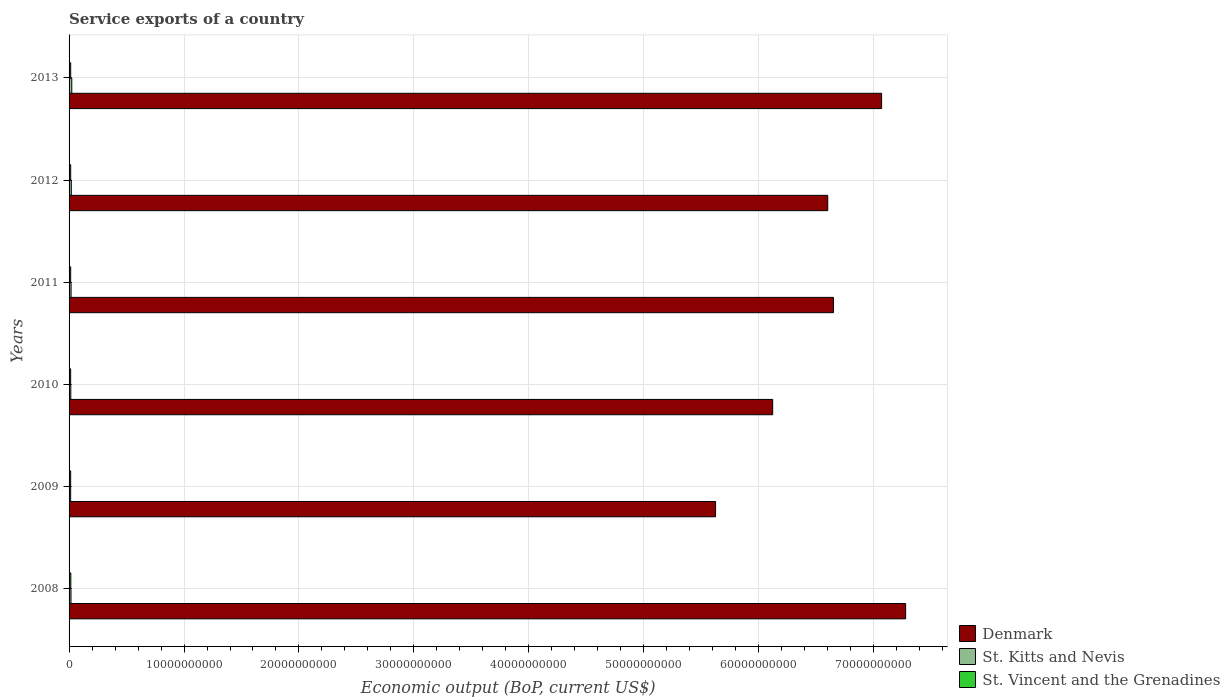Are the number of bars per tick equal to the number of legend labels?
Give a very brief answer. Yes. Are the number of bars on each tick of the Y-axis equal?
Provide a succinct answer. Yes. How many bars are there on the 3rd tick from the top?
Your answer should be very brief. 3. How many bars are there on the 1st tick from the bottom?
Offer a terse response. 3. What is the label of the 1st group of bars from the top?
Offer a terse response. 2013. What is the service exports in St. Kitts and Nevis in 2008?
Make the answer very short. 1.66e+08. Across all years, what is the maximum service exports in St. Vincent and the Grenadines?
Your answer should be very brief. 1.53e+08. Across all years, what is the minimum service exports in St. Kitts and Nevis?
Provide a succinct answer. 1.37e+08. In which year was the service exports in St. Kitts and Nevis maximum?
Offer a very short reply. 2013. In which year was the service exports in St. Kitts and Nevis minimum?
Make the answer very short. 2009. What is the total service exports in St. Kitts and Nevis in the graph?
Ensure brevity in your answer.  1.06e+09. What is the difference between the service exports in Denmark in 2010 and that in 2012?
Your answer should be compact. -4.79e+09. What is the difference between the service exports in Denmark in 2011 and the service exports in St. Kitts and Nevis in 2008?
Make the answer very short. 6.63e+1. What is the average service exports in St. Kitts and Nevis per year?
Give a very brief answer. 1.76e+08. In the year 2008, what is the difference between the service exports in St. Kitts and Nevis and service exports in St. Vincent and the Grenadines?
Offer a terse response. 1.28e+07. What is the ratio of the service exports in St. Kitts and Nevis in 2008 to that in 2013?
Keep it short and to the point. 0.7. Is the service exports in St. Kitts and Nevis in 2008 less than that in 2011?
Offer a terse response. Yes. What is the difference between the highest and the second highest service exports in St. Kitts and Nevis?
Provide a short and direct response. 4.17e+07. What is the difference between the highest and the lowest service exports in St. Vincent and the Grenadines?
Offer a terse response. 1.48e+07. What does the 1st bar from the top in 2013 represents?
Your answer should be compact. St. Vincent and the Grenadines. What does the 2nd bar from the bottom in 2008 represents?
Your answer should be very brief. St. Kitts and Nevis. Is it the case that in every year, the sum of the service exports in St. Vincent and the Grenadines and service exports in Denmark is greater than the service exports in St. Kitts and Nevis?
Ensure brevity in your answer.  Yes. How many bars are there?
Make the answer very short. 18. How many years are there in the graph?
Your answer should be compact. 6. What is the difference between two consecutive major ticks on the X-axis?
Give a very brief answer. 1.00e+1. Does the graph contain grids?
Keep it short and to the point. Yes. Where does the legend appear in the graph?
Ensure brevity in your answer.  Bottom right. How are the legend labels stacked?
Give a very brief answer. Vertical. What is the title of the graph?
Offer a very short reply. Service exports of a country. Does "Aruba" appear as one of the legend labels in the graph?
Provide a succinct answer. No. What is the label or title of the X-axis?
Your answer should be compact. Economic output (BoP, current US$). What is the label or title of the Y-axis?
Provide a short and direct response. Years. What is the Economic output (BoP, current US$) in Denmark in 2008?
Offer a very short reply. 7.28e+1. What is the Economic output (BoP, current US$) of St. Kitts and Nevis in 2008?
Your response must be concise. 1.66e+08. What is the Economic output (BoP, current US$) in St. Vincent and the Grenadines in 2008?
Make the answer very short. 1.53e+08. What is the Economic output (BoP, current US$) of Denmark in 2009?
Offer a very short reply. 5.62e+1. What is the Economic output (BoP, current US$) of St. Kitts and Nevis in 2009?
Offer a terse response. 1.37e+08. What is the Economic output (BoP, current US$) in St. Vincent and the Grenadines in 2009?
Offer a terse response. 1.39e+08. What is the Economic output (BoP, current US$) of Denmark in 2010?
Your answer should be compact. 6.12e+1. What is the Economic output (BoP, current US$) in St. Kitts and Nevis in 2010?
Your response must be concise. 1.50e+08. What is the Economic output (BoP, current US$) of St. Vincent and the Grenadines in 2010?
Make the answer very short. 1.38e+08. What is the Economic output (BoP, current US$) in Denmark in 2011?
Make the answer very short. 6.65e+1. What is the Economic output (BoP, current US$) of St. Kitts and Nevis in 2011?
Your answer should be compact. 1.75e+08. What is the Economic output (BoP, current US$) in St. Vincent and the Grenadines in 2011?
Offer a terse response. 1.39e+08. What is the Economic output (BoP, current US$) in Denmark in 2012?
Your answer should be very brief. 6.60e+1. What is the Economic output (BoP, current US$) in St. Kitts and Nevis in 2012?
Ensure brevity in your answer.  1.94e+08. What is the Economic output (BoP, current US$) in St. Vincent and the Grenadines in 2012?
Provide a short and direct response. 1.40e+08. What is the Economic output (BoP, current US$) in Denmark in 2013?
Make the answer very short. 7.07e+1. What is the Economic output (BoP, current US$) in St. Kitts and Nevis in 2013?
Your answer should be compact. 2.36e+08. What is the Economic output (BoP, current US$) in St. Vincent and the Grenadines in 2013?
Ensure brevity in your answer.  1.41e+08. Across all years, what is the maximum Economic output (BoP, current US$) in Denmark?
Make the answer very short. 7.28e+1. Across all years, what is the maximum Economic output (BoP, current US$) in St. Kitts and Nevis?
Give a very brief answer. 2.36e+08. Across all years, what is the maximum Economic output (BoP, current US$) in St. Vincent and the Grenadines?
Provide a short and direct response. 1.53e+08. Across all years, what is the minimum Economic output (BoP, current US$) in Denmark?
Give a very brief answer. 5.62e+1. Across all years, what is the minimum Economic output (BoP, current US$) of St. Kitts and Nevis?
Make the answer very short. 1.37e+08. Across all years, what is the minimum Economic output (BoP, current US$) of St. Vincent and the Grenadines?
Your response must be concise. 1.38e+08. What is the total Economic output (BoP, current US$) in Denmark in the graph?
Provide a short and direct response. 3.93e+11. What is the total Economic output (BoP, current US$) in St. Kitts and Nevis in the graph?
Provide a short and direct response. 1.06e+09. What is the total Economic output (BoP, current US$) in St. Vincent and the Grenadines in the graph?
Ensure brevity in your answer.  8.51e+08. What is the difference between the Economic output (BoP, current US$) in Denmark in 2008 and that in 2009?
Provide a short and direct response. 1.65e+1. What is the difference between the Economic output (BoP, current US$) of St. Kitts and Nevis in 2008 and that in 2009?
Provide a succinct answer. 2.85e+07. What is the difference between the Economic output (BoP, current US$) of St. Vincent and the Grenadines in 2008 and that in 2009?
Provide a short and direct response. 1.40e+07. What is the difference between the Economic output (BoP, current US$) in Denmark in 2008 and that in 2010?
Ensure brevity in your answer.  1.16e+1. What is the difference between the Economic output (BoP, current US$) of St. Kitts and Nevis in 2008 and that in 2010?
Keep it short and to the point. 1.56e+07. What is the difference between the Economic output (BoP, current US$) in St. Vincent and the Grenadines in 2008 and that in 2010?
Ensure brevity in your answer.  1.48e+07. What is the difference between the Economic output (BoP, current US$) of Denmark in 2008 and that in 2011?
Make the answer very short. 6.28e+09. What is the difference between the Economic output (BoP, current US$) of St. Kitts and Nevis in 2008 and that in 2011?
Your answer should be very brief. -9.02e+06. What is the difference between the Economic output (BoP, current US$) of St. Vincent and the Grenadines in 2008 and that in 2011?
Your response must be concise. 1.36e+07. What is the difference between the Economic output (BoP, current US$) of Denmark in 2008 and that in 2012?
Provide a succinct answer. 6.78e+09. What is the difference between the Economic output (BoP, current US$) of St. Kitts and Nevis in 2008 and that in 2012?
Offer a terse response. -2.86e+07. What is the difference between the Economic output (BoP, current US$) of St. Vincent and the Grenadines in 2008 and that in 2012?
Your answer should be very brief. 1.25e+07. What is the difference between the Economic output (BoP, current US$) in Denmark in 2008 and that in 2013?
Provide a succinct answer. 2.09e+09. What is the difference between the Economic output (BoP, current US$) in St. Kitts and Nevis in 2008 and that in 2013?
Provide a succinct answer. -7.04e+07. What is the difference between the Economic output (BoP, current US$) of St. Vincent and the Grenadines in 2008 and that in 2013?
Your response must be concise. 1.23e+07. What is the difference between the Economic output (BoP, current US$) in Denmark in 2009 and that in 2010?
Make the answer very short. -4.97e+09. What is the difference between the Economic output (BoP, current US$) in St. Kitts and Nevis in 2009 and that in 2010?
Offer a terse response. -1.29e+07. What is the difference between the Economic output (BoP, current US$) of St. Vincent and the Grenadines in 2009 and that in 2010?
Your answer should be very brief. 7.68e+05. What is the difference between the Economic output (BoP, current US$) of Denmark in 2009 and that in 2011?
Ensure brevity in your answer.  -1.03e+1. What is the difference between the Economic output (BoP, current US$) in St. Kitts and Nevis in 2009 and that in 2011?
Your answer should be very brief. -3.75e+07. What is the difference between the Economic output (BoP, current US$) in St. Vincent and the Grenadines in 2009 and that in 2011?
Provide a short and direct response. -4.17e+05. What is the difference between the Economic output (BoP, current US$) of Denmark in 2009 and that in 2012?
Offer a terse response. -9.76e+09. What is the difference between the Economic output (BoP, current US$) of St. Kitts and Nevis in 2009 and that in 2012?
Keep it short and to the point. -5.71e+07. What is the difference between the Economic output (BoP, current US$) in St. Vincent and the Grenadines in 2009 and that in 2012?
Your response must be concise. -1.53e+06. What is the difference between the Economic output (BoP, current US$) of Denmark in 2009 and that in 2013?
Provide a short and direct response. -1.44e+1. What is the difference between the Economic output (BoP, current US$) of St. Kitts and Nevis in 2009 and that in 2013?
Your response must be concise. -9.88e+07. What is the difference between the Economic output (BoP, current US$) of St. Vincent and the Grenadines in 2009 and that in 2013?
Ensure brevity in your answer.  -1.71e+06. What is the difference between the Economic output (BoP, current US$) of Denmark in 2010 and that in 2011?
Offer a very short reply. -5.28e+09. What is the difference between the Economic output (BoP, current US$) in St. Kitts and Nevis in 2010 and that in 2011?
Provide a succinct answer. -2.46e+07. What is the difference between the Economic output (BoP, current US$) of St. Vincent and the Grenadines in 2010 and that in 2011?
Your answer should be compact. -1.19e+06. What is the difference between the Economic output (BoP, current US$) of Denmark in 2010 and that in 2012?
Offer a terse response. -4.79e+09. What is the difference between the Economic output (BoP, current US$) in St. Kitts and Nevis in 2010 and that in 2012?
Your answer should be compact. -4.42e+07. What is the difference between the Economic output (BoP, current US$) in St. Vincent and the Grenadines in 2010 and that in 2012?
Give a very brief answer. -2.30e+06. What is the difference between the Economic output (BoP, current US$) of Denmark in 2010 and that in 2013?
Ensure brevity in your answer.  -9.47e+09. What is the difference between the Economic output (BoP, current US$) in St. Kitts and Nevis in 2010 and that in 2013?
Provide a short and direct response. -8.59e+07. What is the difference between the Economic output (BoP, current US$) of St. Vincent and the Grenadines in 2010 and that in 2013?
Your response must be concise. -2.48e+06. What is the difference between the Economic output (BoP, current US$) in Denmark in 2011 and that in 2012?
Your answer should be compact. 4.95e+08. What is the difference between the Economic output (BoP, current US$) of St. Kitts and Nevis in 2011 and that in 2012?
Your answer should be very brief. -1.96e+07. What is the difference between the Economic output (BoP, current US$) of St. Vincent and the Grenadines in 2011 and that in 2012?
Your answer should be very brief. -1.12e+06. What is the difference between the Economic output (BoP, current US$) in Denmark in 2011 and that in 2013?
Your answer should be compact. -4.19e+09. What is the difference between the Economic output (BoP, current US$) of St. Kitts and Nevis in 2011 and that in 2013?
Provide a succinct answer. -6.13e+07. What is the difference between the Economic output (BoP, current US$) of St. Vincent and the Grenadines in 2011 and that in 2013?
Your answer should be compact. -1.30e+06. What is the difference between the Economic output (BoP, current US$) of Denmark in 2012 and that in 2013?
Give a very brief answer. -4.69e+09. What is the difference between the Economic output (BoP, current US$) in St. Kitts and Nevis in 2012 and that in 2013?
Your answer should be compact. -4.17e+07. What is the difference between the Economic output (BoP, current US$) of St. Vincent and the Grenadines in 2012 and that in 2013?
Give a very brief answer. -1.79e+05. What is the difference between the Economic output (BoP, current US$) of Denmark in 2008 and the Economic output (BoP, current US$) of St. Kitts and Nevis in 2009?
Offer a very short reply. 7.26e+1. What is the difference between the Economic output (BoP, current US$) in Denmark in 2008 and the Economic output (BoP, current US$) in St. Vincent and the Grenadines in 2009?
Offer a very short reply. 7.26e+1. What is the difference between the Economic output (BoP, current US$) in St. Kitts and Nevis in 2008 and the Economic output (BoP, current US$) in St. Vincent and the Grenadines in 2009?
Your response must be concise. 2.69e+07. What is the difference between the Economic output (BoP, current US$) of Denmark in 2008 and the Economic output (BoP, current US$) of St. Kitts and Nevis in 2010?
Your answer should be very brief. 7.26e+1. What is the difference between the Economic output (BoP, current US$) in Denmark in 2008 and the Economic output (BoP, current US$) in St. Vincent and the Grenadines in 2010?
Your answer should be compact. 7.26e+1. What is the difference between the Economic output (BoP, current US$) of St. Kitts and Nevis in 2008 and the Economic output (BoP, current US$) of St. Vincent and the Grenadines in 2010?
Keep it short and to the point. 2.76e+07. What is the difference between the Economic output (BoP, current US$) of Denmark in 2008 and the Economic output (BoP, current US$) of St. Kitts and Nevis in 2011?
Provide a succinct answer. 7.26e+1. What is the difference between the Economic output (BoP, current US$) of Denmark in 2008 and the Economic output (BoP, current US$) of St. Vincent and the Grenadines in 2011?
Your answer should be compact. 7.26e+1. What is the difference between the Economic output (BoP, current US$) in St. Kitts and Nevis in 2008 and the Economic output (BoP, current US$) in St. Vincent and the Grenadines in 2011?
Keep it short and to the point. 2.64e+07. What is the difference between the Economic output (BoP, current US$) of Denmark in 2008 and the Economic output (BoP, current US$) of St. Kitts and Nevis in 2012?
Provide a short and direct response. 7.26e+1. What is the difference between the Economic output (BoP, current US$) of Denmark in 2008 and the Economic output (BoP, current US$) of St. Vincent and the Grenadines in 2012?
Your answer should be very brief. 7.26e+1. What is the difference between the Economic output (BoP, current US$) in St. Kitts and Nevis in 2008 and the Economic output (BoP, current US$) in St. Vincent and the Grenadines in 2012?
Your answer should be very brief. 2.53e+07. What is the difference between the Economic output (BoP, current US$) of Denmark in 2008 and the Economic output (BoP, current US$) of St. Kitts and Nevis in 2013?
Keep it short and to the point. 7.25e+1. What is the difference between the Economic output (BoP, current US$) in Denmark in 2008 and the Economic output (BoP, current US$) in St. Vincent and the Grenadines in 2013?
Ensure brevity in your answer.  7.26e+1. What is the difference between the Economic output (BoP, current US$) of St. Kitts and Nevis in 2008 and the Economic output (BoP, current US$) of St. Vincent and the Grenadines in 2013?
Your answer should be compact. 2.52e+07. What is the difference between the Economic output (BoP, current US$) of Denmark in 2009 and the Economic output (BoP, current US$) of St. Kitts and Nevis in 2010?
Your answer should be compact. 5.61e+1. What is the difference between the Economic output (BoP, current US$) of Denmark in 2009 and the Economic output (BoP, current US$) of St. Vincent and the Grenadines in 2010?
Provide a succinct answer. 5.61e+1. What is the difference between the Economic output (BoP, current US$) of St. Kitts and Nevis in 2009 and the Economic output (BoP, current US$) of St. Vincent and the Grenadines in 2010?
Your response must be concise. -8.49e+05. What is the difference between the Economic output (BoP, current US$) in Denmark in 2009 and the Economic output (BoP, current US$) in St. Kitts and Nevis in 2011?
Keep it short and to the point. 5.61e+1. What is the difference between the Economic output (BoP, current US$) of Denmark in 2009 and the Economic output (BoP, current US$) of St. Vincent and the Grenadines in 2011?
Your answer should be very brief. 5.61e+1. What is the difference between the Economic output (BoP, current US$) in St. Kitts and Nevis in 2009 and the Economic output (BoP, current US$) in St. Vincent and the Grenadines in 2011?
Your answer should be very brief. -2.03e+06. What is the difference between the Economic output (BoP, current US$) of Denmark in 2009 and the Economic output (BoP, current US$) of St. Kitts and Nevis in 2012?
Provide a succinct answer. 5.60e+1. What is the difference between the Economic output (BoP, current US$) of Denmark in 2009 and the Economic output (BoP, current US$) of St. Vincent and the Grenadines in 2012?
Give a very brief answer. 5.61e+1. What is the difference between the Economic output (BoP, current US$) of St. Kitts and Nevis in 2009 and the Economic output (BoP, current US$) of St. Vincent and the Grenadines in 2012?
Offer a very short reply. -3.15e+06. What is the difference between the Economic output (BoP, current US$) of Denmark in 2009 and the Economic output (BoP, current US$) of St. Kitts and Nevis in 2013?
Your answer should be compact. 5.60e+1. What is the difference between the Economic output (BoP, current US$) in Denmark in 2009 and the Economic output (BoP, current US$) in St. Vincent and the Grenadines in 2013?
Your response must be concise. 5.61e+1. What is the difference between the Economic output (BoP, current US$) of St. Kitts and Nevis in 2009 and the Economic output (BoP, current US$) of St. Vincent and the Grenadines in 2013?
Your answer should be compact. -3.33e+06. What is the difference between the Economic output (BoP, current US$) of Denmark in 2010 and the Economic output (BoP, current US$) of St. Kitts and Nevis in 2011?
Your answer should be very brief. 6.10e+1. What is the difference between the Economic output (BoP, current US$) of Denmark in 2010 and the Economic output (BoP, current US$) of St. Vincent and the Grenadines in 2011?
Your answer should be compact. 6.11e+1. What is the difference between the Economic output (BoP, current US$) of St. Kitts and Nevis in 2010 and the Economic output (BoP, current US$) of St. Vincent and the Grenadines in 2011?
Keep it short and to the point. 1.09e+07. What is the difference between the Economic output (BoP, current US$) of Denmark in 2010 and the Economic output (BoP, current US$) of St. Kitts and Nevis in 2012?
Your response must be concise. 6.10e+1. What is the difference between the Economic output (BoP, current US$) of Denmark in 2010 and the Economic output (BoP, current US$) of St. Vincent and the Grenadines in 2012?
Give a very brief answer. 6.11e+1. What is the difference between the Economic output (BoP, current US$) in St. Kitts and Nevis in 2010 and the Economic output (BoP, current US$) in St. Vincent and the Grenadines in 2012?
Offer a very short reply. 9.74e+06. What is the difference between the Economic output (BoP, current US$) in Denmark in 2010 and the Economic output (BoP, current US$) in St. Kitts and Nevis in 2013?
Ensure brevity in your answer.  6.10e+1. What is the difference between the Economic output (BoP, current US$) of Denmark in 2010 and the Economic output (BoP, current US$) of St. Vincent and the Grenadines in 2013?
Offer a terse response. 6.11e+1. What is the difference between the Economic output (BoP, current US$) of St. Kitts and Nevis in 2010 and the Economic output (BoP, current US$) of St. Vincent and the Grenadines in 2013?
Keep it short and to the point. 9.56e+06. What is the difference between the Economic output (BoP, current US$) of Denmark in 2011 and the Economic output (BoP, current US$) of St. Kitts and Nevis in 2012?
Offer a very short reply. 6.63e+1. What is the difference between the Economic output (BoP, current US$) of Denmark in 2011 and the Economic output (BoP, current US$) of St. Vincent and the Grenadines in 2012?
Make the answer very short. 6.64e+1. What is the difference between the Economic output (BoP, current US$) in St. Kitts and Nevis in 2011 and the Economic output (BoP, current US$) in St. Vincent and the Grenadines in 2012?
Offer a terse response. 3.43e+07. What is the difference between the Economic output (BoP, current US$) of Denmark in 2011 and the Economic output (BoP, current US$) of St. Kitts and Nevis in 2013?
Ensure brevity in your answer.  6.63e+1. What is the difference between the Economic output (BoP, current US$) of Denmark in 2011 and the Economic output (BoP, current US$) of St. Vincent and the Grenadines in 2013?
Offer a terse response. 6.64e+1. What is the difference between the Economic output (BoP, current US$) in St. Kitts and Nevis in 2011 and the Economic output (BoP, current US$) in St. Vincent and the Grenadines in 2013?
Your response must be concise. 3.42e+07. What is the difference between the Economic output (BoP, current US$) of Denmark in 2012 and the Economic output (BoP, current US$) of St. Kitts and Nevis in 2013?
Your answer should be compact. 6.58e+1. What is the difference between the Economic output (BoP, current US$) of Denmark in 2012 and the Economic output (BoP, current US$) of St. Vincent and the Grenadines in 2013?
Your answer should be compact. 6.59e+1. What is the difference between the Economic output (BoP, current US$) of St. Kitts and Nevis in 2012 and the Economic output (BoP, current US$) of St. Vincent and the Grenadines in 2013?
Offer a very short reply. 5.38e+07. What is the average Economic output (BoP, current US$) in Denmark per year?
Ensure brevity in your answer.  6.56e+1. What is the average Economic output (BoP, current US$) in St. Kitts and Nevis per year?
Ensure brevity in your answer.  1.76e+08. What is the average Economic output (BoP, current US$) of St. Vincent and the Grenadines per year?
Your answer should be very brief. 1.42e+08. In the year 2008, what is the difference between the Economic output (BoP, current US$) of Denmark and Economic output (BoP, current US$) of St. Kitts and Nevis?
Make the answer very short. 7.26e+1. In the year 2008, what is the difference between the Economic output (BoP, current US$) of Denmark and Economic output (BoP, current US$) of St. Vincent and the Grenadines?
Ensure brevity in your answer.  7.26e+1. In the year 2008, what is the difference between the Economic output (BoP, current US$) of St. Kitts and Nevis and Economic output (BoP, current US$) of St. Vincent and the Grenadines?
Your answer should be compact. 1.28e+07. In the year 2009, what is the difference between the Economic output (BoP, current US$) of Denmark and Economic output (BoP, current US$) of St. Kitts and Nevis?
Your answer should be compact. 5.61e+1. In the year 2009, what is the difference between the Economic output (BoP, current US$) in Denmark and Economic output (BoP, current US$) in St. Vincent and the Grenadines?
Offer a very short reply. 5.61e+1. In the year 2009, what is the difference between the Economic output (BoP, current US$) of St. Kitts and Nevis and Economic output (BoP, current US$) of St. Vincent and the Grenadines?
Offer a terse response. -1.62e+06. In the year 2010, what is the difference between the Economic output (BoP, current US$) of Denmark and Economic output (BoP, current US$) of St. Kitts and Nevis?
Provide a succinct answer. 6.11e+1. In the year 2010, what is the difference between the Economic output (BoP, current US$) in Denmark and Economic output (BoP, current US$) in St. Vincent and the Grenadines?
Offer a very short reply. 6.11e+1. In the year 2010, what is the difference between the Economic output (BoP, current US$) of St. Kitts and Nevis and Economic output (BoP, current US$) of St. Vincent and the Grenadines?
Your answer should be compact. 1.20e+07. In the year 2011, what is the difference between the Economic output (BoP, current US$) of Denmark and Economic output (BoP, current US$) of St. Kitts and Nevis?
Your response must be concise. 6.63e+1. In the year 2011, what is the difference between the Economic output (BoP, current US$) of Denmark and Economic output (BoP, current US$) of St. Vincent and the Grenadines?
Offer a terse response. 6.64e+1. In the year 2011, what is the difference between the Economic output (BoP, current US$) in St. Kitts and Nevis and Economic output (BoP, current US$) in St. Vincent and the Grenadines?
Your answer should be compact. 3.55e+07. In the year 2012, what is the difference between the Economic output (BoP, current US$) of Denmark and Economic output (BoP, current US$) of St. Kitts and Nevis?
Keep it short and to the point. 6.58e+1. In the year 2012, what is the difference between the Economic output (BoP, current US$) of Denmark and Economic output (BoP, current US$) of St. Vincent and the Grenadines?
Offer a very short reply. 6.59e+1. In the year 2012, what is the difference between the Economic output (BoP, current US$) in St. Kitts and Nevis and Economic output (BoP, current US$) in St. Vincent and the Grenadines?
Make the answer very short. 5.39e+07. In the year 2013, what is the difference between the Economic output (BoP, current US$) of Denmark and Economic output (BoP, current US$) of St. Kitts and Nevis?
Offer a very short reply. 7.04e+1. In the year 2013, what is the difference between the Economic output (BoP, current US$) of Denmark and Economic output (BoP, current US$) of St. Vincent and the Grenadines?
Make the answer very short. 7.05e+1. In the year 2013, what is the difference between the Economic output (BoP, current US$) of St. Kitts and Nevis and Economic output (BoP, current US$) of St. Vincent and the Grenadines?
Your answer should be compact. 9.55e+07. What is the ratio of the Economic output (BoP, current US$) of Denmark in 2008 to that in 2009?
Give a very brief answer. 1.29. What is the ratio of the Economic output (BoP, current US$) of St. Kitts and Nevis in 2008 to that in 2009?
Your response must be concise. 1.21. What is the ratio of the Economic output (BoP, current US$) in St. Vincent and the Grenadines in 2008 to that in 2009?
Offer a terse response. 1.1. What is the ratio of the Economic output (BoP, current US$) of Denmark in 2008 to that in 2010?
Your answer should be very brief. 1.19. What is the ratio of the Economic output (BoP, current US$) in St. Kitts and Nevis in 2008 to that in 2010?
Ensure brevity in your answer.  1.1. What is the ratio of the Economic output (BoP, current US$) in St. Vincent and the Grenadines in 2008 to that in 2010?
Offer a terse response. 1.11. What is the ratio of the Economic output (BoP, current US$) in Denmark in 2008 to that in 2011?
Your response must be concise. 1.09. What is the ratio of the Economic output (BoP, current US$) in St. Kitts and Nevis in 2008 to that in 2011?
Keep it short and to the point. 0.95. What is the ratio of the Economic output (BoP, current US$) of St. Vincent and the Grenadines in 2008 to that in 2011?
Your answer should be compact. 1.1. What is the ratio of the Economic output (BoP, current US$) in Denmark in 2008 to that in 2012?
Your answer should be very brief. 1.1. What is the ratio of the Economic output (BoP, current US$) of St. Kitts and Nevis in 2008 to that in 2012?
Ensure brevity in your answer.  0.85. What is the ratio of the Economic output (BoP, current US$) in St. Vincent and the Grenadines in 2008 to that in 2012?
Your response must be concise. 1.09. What is the ratio of the Economic output (BoP, current US$) in Denmark in 2008 to that in 2013?
Offer a very short reply. 1.03. What is the ratio of the Economic output (BoP, current US$) in St. Kitts and Nevis in 2008 to that in 2013?
Ensure brevity in your answer.  0.7. What is the ratio of the Economic output (BoP, current US$) in St. Vincent and the Grenadines in 2008 to that in 2013?
Keep it short and to the point. 1.09. What is the ratio of the Economic output (BoP, current US$) of Denmark in 2009 to that in 2010?
Keep it short and to the point. 0.92. What is the ratio of the Economic output (BoP, current US$) in St. Kitts and Nevis in 2009 to that in 2010?
Ensure brevity in your answer.  0.91. What is the ratio of the Economic output (BoP, current US$) of St. Vincent and the Grenadines in 2009 to that in 2010?
Your answer should be compact. 1.01. What is the ratio of the Economic output (BoP, current US$) in Denmark in 2009 to that in 2011?
Your answer should be compact. 0.85. What is the ratio of the Economic output (BoP, current US$) of St. Kitts and Nevis in 2009 to that in 2011?
Your answer should be compact. 0.79. What is the ratio of the Economic output (BoP, current US$) of St. Vincent and the Grenadines in 2009 to that in 2011?
Your answer should be very brief. 1. What is the ratio of the Economic output (BoP, current US$) in Denmark in 2009 to that in 2012?
Give a very brief answer. 0.85. What is the ratio of the Economic output (BoP, current US$) of St. Kitts and Nevis in 2009 to that in 2012?
Offer a terse response. 0.71. What is the ratio of the Economic output (BoP, current US$) in Denmark in 2009 to that in 2013?
Keep it short and to the point. 0.8. What is the ratio of the Economic output (BoP, current US$) in St. Kitts and Nevis in 2009 to that in 2013?
Ensure brevity in your answer.  0.58. What is the ratio of the Economic output (BoP, current US$) in Denmark in 2010 to that in 2011?
Offer a terse response. 0.92. What is the ratio of the Economic output (BoP, current US$) of St. Kitts and Nevis in 2010 to that in 2011?
Keep it short and to the point. 0.86. What is the ratio of the Economic output (BoP, current US$) in St. Vincent and the Grenadines in 2010 to that in 2011?
Your answer should be compact. 0.99. What is the ratio of the Economic output (BoP, current US$) in Denmark in 2010 to that in 2012?
Keep it short and to the point. 0.93. What is the ratio of the Economic output (BoP, current US$) in St. Kitts and Nevis in 2010 to that in 2012?
Give a very brief answer. 0.77. What is the ratio of the Economic output (BoP, current US$) in St. Vincent and the Grenadines in 2010 to that in 2012?
Ensure brevity in your answer.  0.98. What is the ratio of the Economic output (BoP, current US$) of Denmark in 2010 to that in 2013?
Give a very brief answer. 0.87. What is the ratio of the Economic output (BoP, current US$) in St. Kitts and Nevis in 2010 to that in 2013?
Keep it short and to the point. 0.64. What is the ratio of the Economic output (BoP, current US$) of St. Vincent and the Grenadines in 2010 to that in 2013?
Provide a succinct answer. 0.98. What is the ratio of the Economic output (BoP, current US$) in Denmark in 2011 to that in 2012?
Offer a terse response. 1.01. What is the ratio of the Economic output (BoP, current US$) in St. Kitts and Nevis in 2011 to that in 2012?
Give a very brief answer. 0.9. What is the ratio of the Economic output (BoP, current US$) in Denmark in 2011 to that in 2013?
Keep it short and to the point. 0.94. What is the ratio of the Economic output (BoP, current US$) in St. Kitts and Nevis in 2011 to that in 2013?
Offer a very short reply. 0.74. What is the ratio of the Economic output (BoP, current US$) of St. Vincent and the Grenadines in 2011 to that in 2013?
Your answer should be compact. 0.99. What is the ratio of the Economic output (BoP, current US$) of Denmark in 2012 to that in 2013?
Provide a short and direct response. 0.93. What is the ratio of the Economic output (BoP, current US$) in St. Kitts and Nevis in 2012 to that in 2013?
Give a very brief answer. 0.82. What is the ratio of the Economic output (BoP, current US$) in St. Vincent and the Grenadines in 2012 to that in 2013?
Your answer should be very brief. 1. What is the difference between the highest and the second highest Economic output (BoP, current US$) of Denmark?
Give a very brief answer. 2.09e+09. What is the difference between the highest and the second highest Economic output (BoP, current US$) of St. Kitts and Nevis?
Your answer should be compact. 4.17e+07. What is the difference between the highest and the second highest Economic output (BoP, current US$) in St. Vincent and the Grenadines?
Keep it short and to the point. 1.23e+07. What is the difference between the highest and the lowest Economic output (BoP, current US$) in Denmark?
Your response must be concise. 1.65e+1. What is the difference between the highest and the lowest Economic output (BoP, current US$) in St. Kitts and Nevis?
Ensure brevity in your answer.  9.88e+07. What is the difference between the highest and the lowest Economic output (BoP, current US$) in St. Vincent and the Grenadines?
Keep it short and to the point. 1.48e+07. 